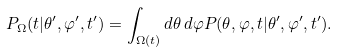<formula> <loc_0><loc_0><loc_500><loc_500>P _ { \Omega } ( t | \theta ^ { \prime } , \varphi ^ { \prime } , t ^ { \prime } ) = \int _ { \Omega ( t ) } d \theta \, d \varphi P ( \theta , \varphi , t | \theta ^ { \prime } , \varphi ^ { \prime } , t ^ { \prime } ) .</formula> 